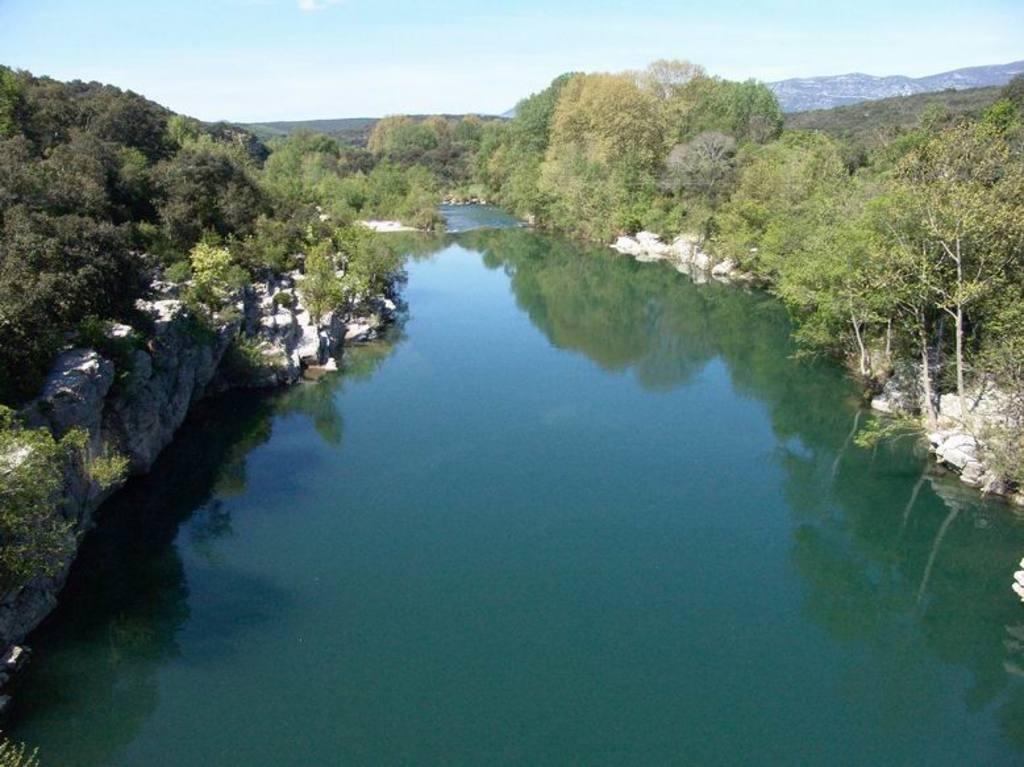Please provide a concise description of this image. In this image we can see the water, rocks, trees on either side, hills and the sky in the background. 